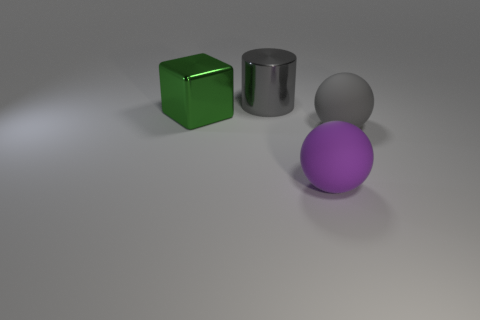Is the number of gray metal cylinders on the left side of the gray cylinder less than the number of big gray objects on the right side of the gray sphere?
Ensure brevity in your answer.  No. Do the purple rubber object and the gray thing that is in front of the metal cube have the same size?
Offer a terse response. Yes. How many rubber things are the same size as the cube?
Provide a succinct answer. 2. What number of big objects are either cyan objects or green things?
Offer a very short reply. 1. Is there a gray cylinder?
Provide a short and direct response. Yes. Is the number of big purple matte objects in front of the big gray metal thing greater than the number of gray rubber objects in front of the purple sphere?
Offer a very short reply. Yes. The sphere to the left of the rubber sphere that is to the right of the purple matte object is what color?
Provide a short and direct response. Purple. Are there any big balls that have the same color as the big block?
Provide a succinct answer. No. There is a ball on the left side of the large gray object in front of the gray thing that is behind the block; how big is it?
Make the answer very short. Large. What shape is the large green shiny thing?
Keep it short and to the point. Cube. 